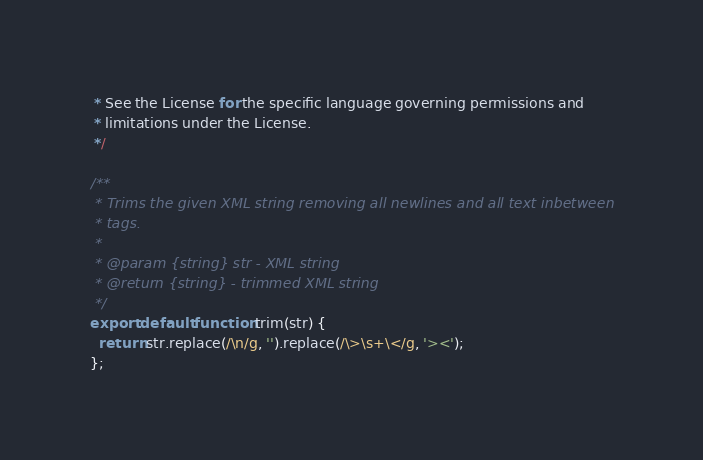<code> <loc_0><loc_0><loc_500><loc_500><_JavaScript_> * See the License for the specific language governing permissions and
 * limitations under the License.
 */

/**
 * Trims the given XML string removing all newlines and all text inbetween
 * tags.
 *
 * @param {string} str - XML string
 * @return {string} - trimmed XML string
 */
export default function trim(str) {
  return str.replace(/\n/g, '').replace(/\>\s+\</g, '><');
};
</code> 